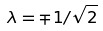<formula> <loc_0><loc_0><loc_500><loc_500>\lambda = \mp 1 / \sqrt { 2 }</formula> 